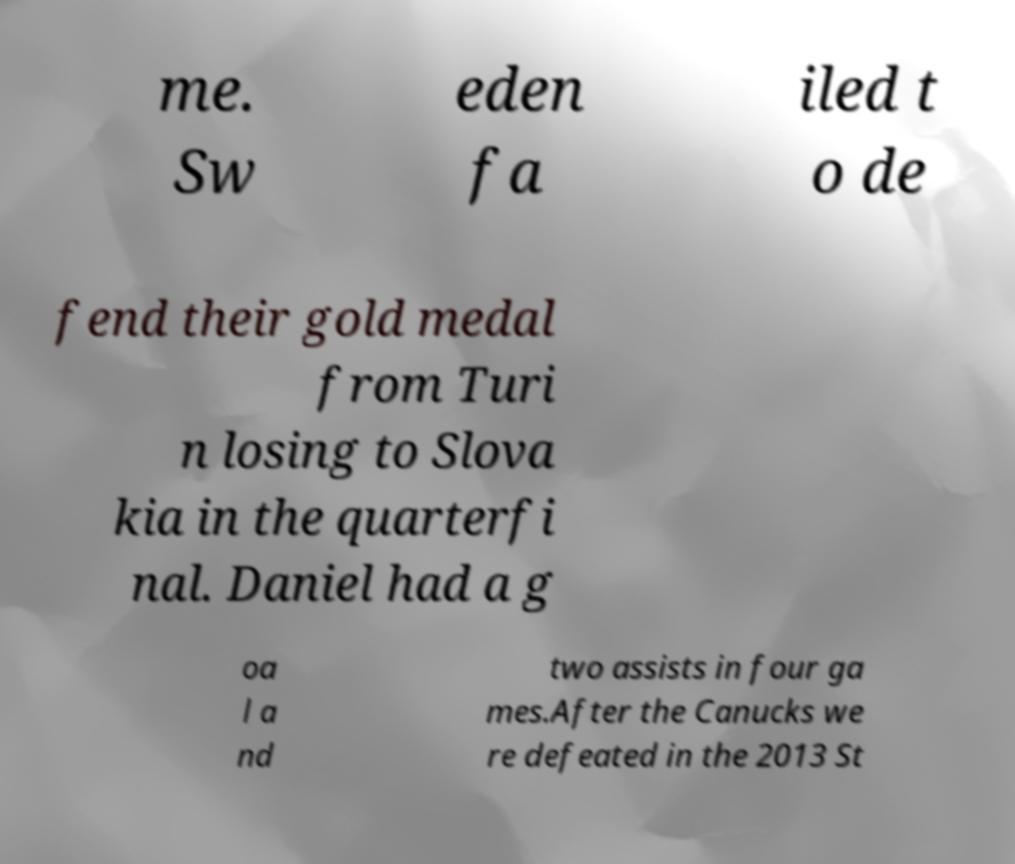What messages or text are displayed in this image? I need them in a readable, typed format. me. Sw eden fa iled t o de fend their gold medal from Turi n losing to Slova kia in the quarterfi nal. Daniel had a g oa l a nd two assists in four ga mes.After the Canucks we re defeated in the 2013 St 